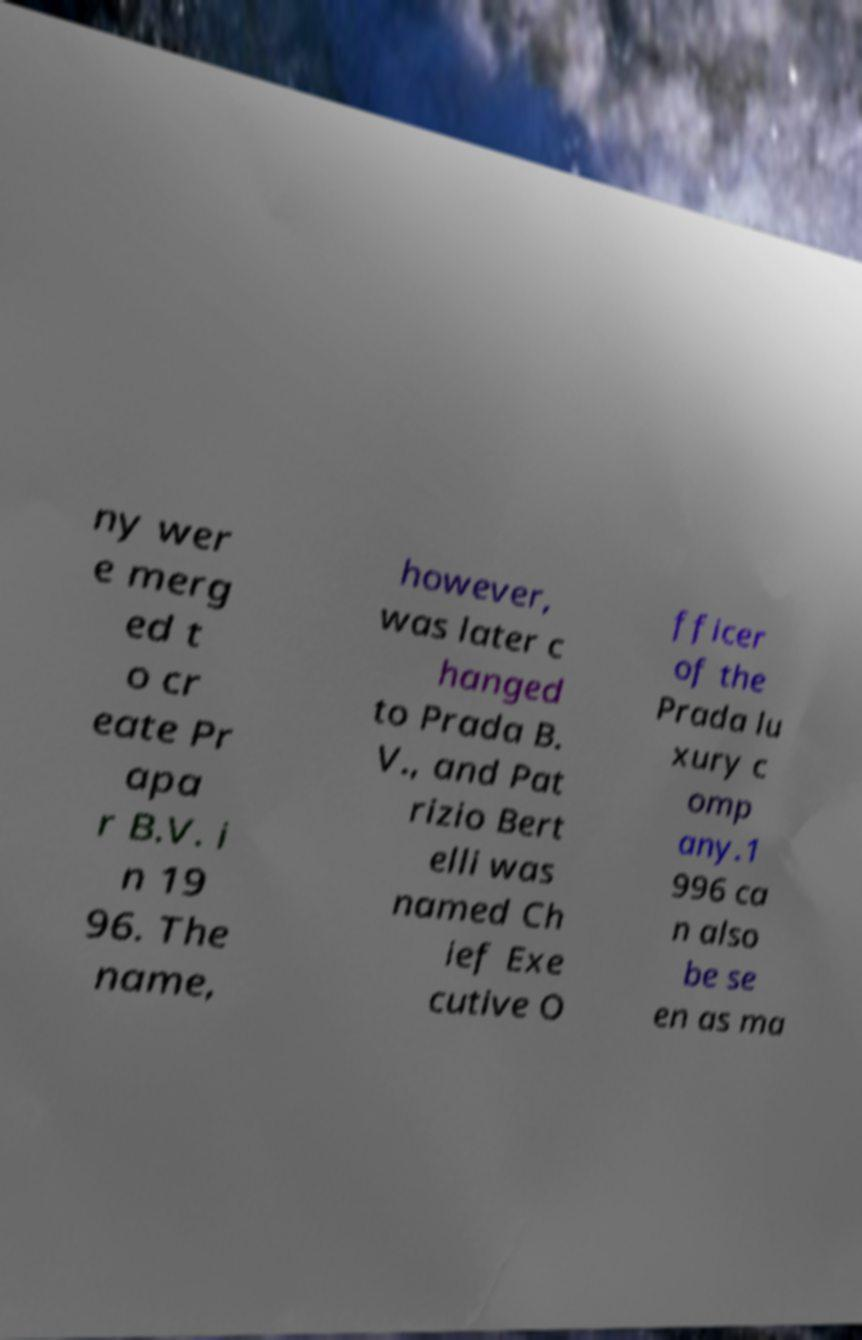Could you assist in decoding the text presented in this image and type it out clearly? ny wer e merg ed t o cr eate Pr apa r B.V. i n 19 96. The name, however, was later c hanged to Prada B. V., and Pat rizio Bert elli was named Ch ief Exe cutive O fficer of the Prada lu xury c omp any.1 996 ca n also be se en as ma 